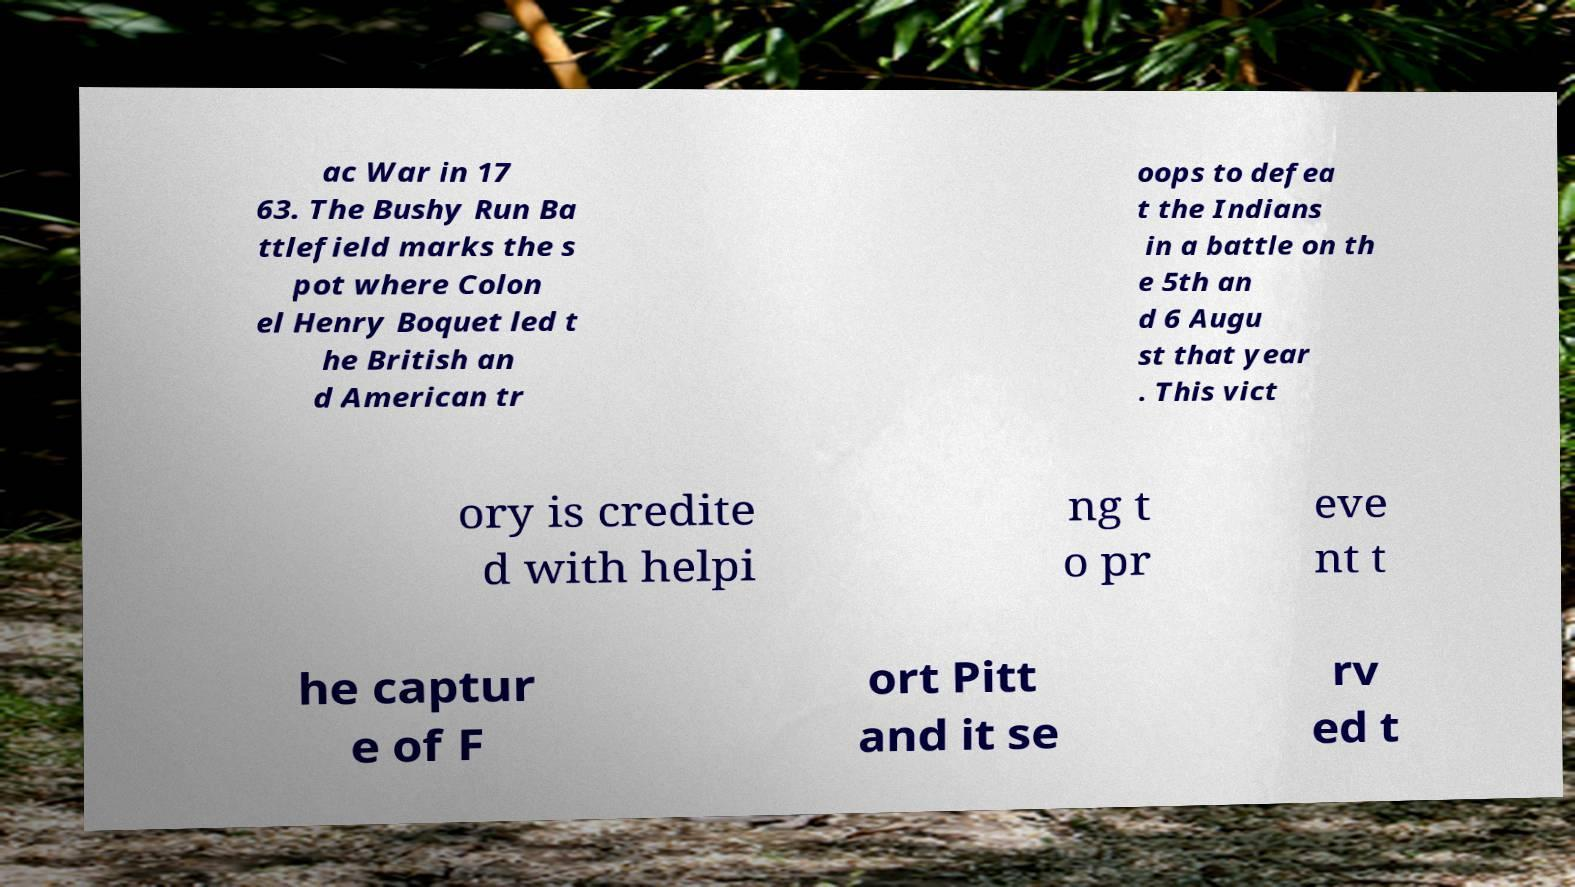Can you read and provide the text displayed in the image?This photo seems to have some interesting text. Can you extract and type it out for me? ac War in 17 63. The Bushy Run Ba ttlefield marks the s pot where Colon el Henry Boquet led t he British an d American tr oops to defea t the Indians in a battle on th e 5th an d 6 Augu st that year . This vict ory is credite d with helpi ng t o pr eve nt t he captur e of F ort Pitt and it se rv ed t 